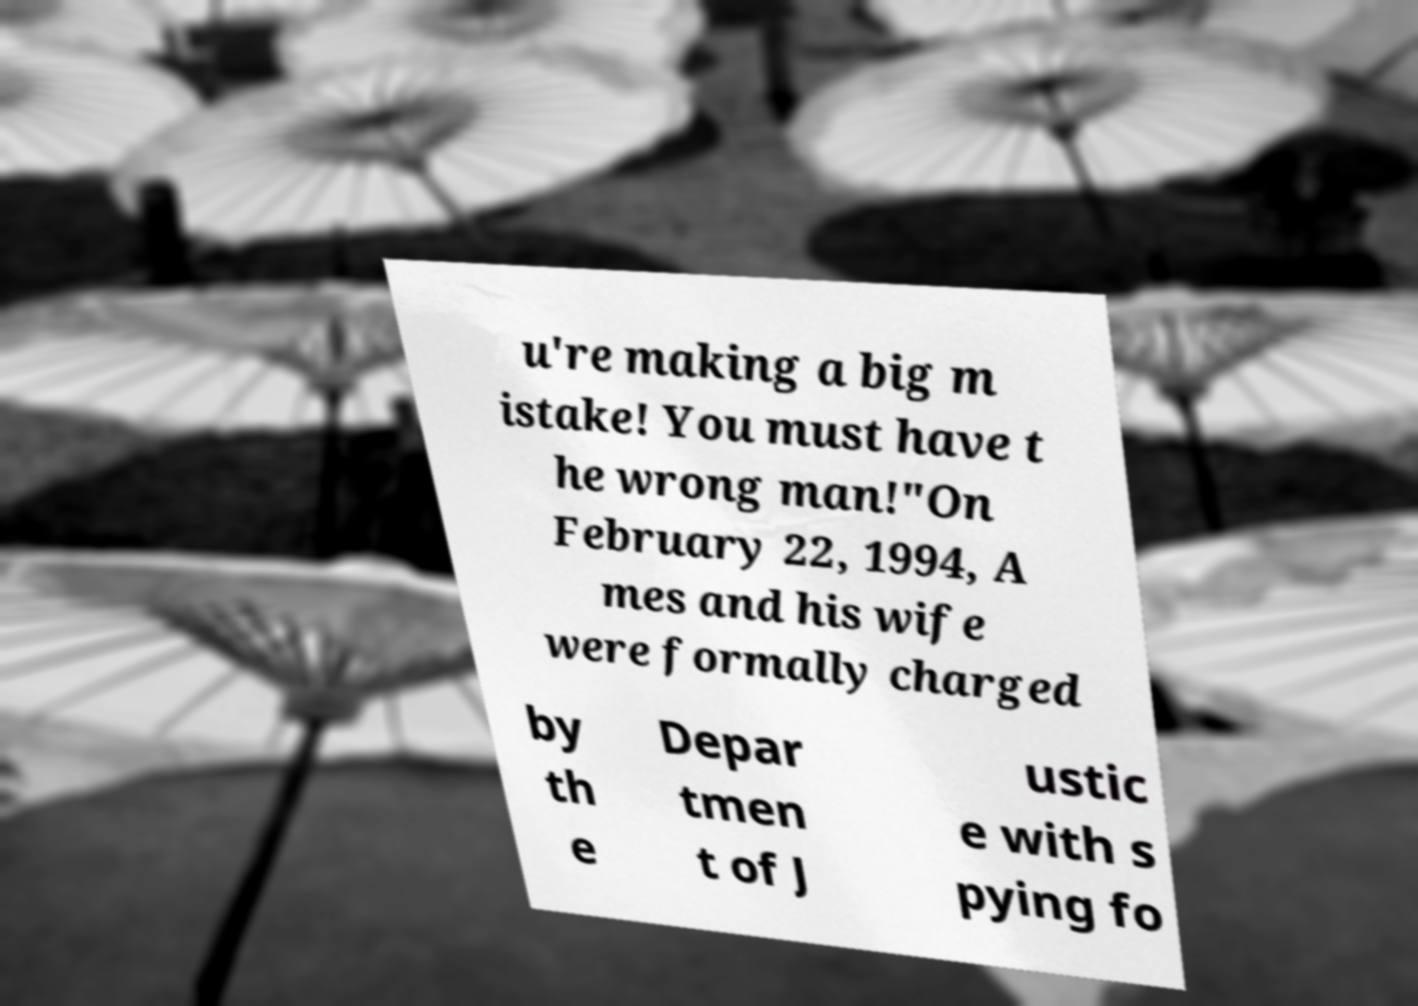Can you read and provide the text displayed in the image?This photo seems to have some interesting text. Can you extract and type it out for me? u're making a big m istake! You must have t he wrong man!"On February 22, 1994, A mes and his wife were formally charged by th e Depar tmen t of J ustic e with s pying fo 